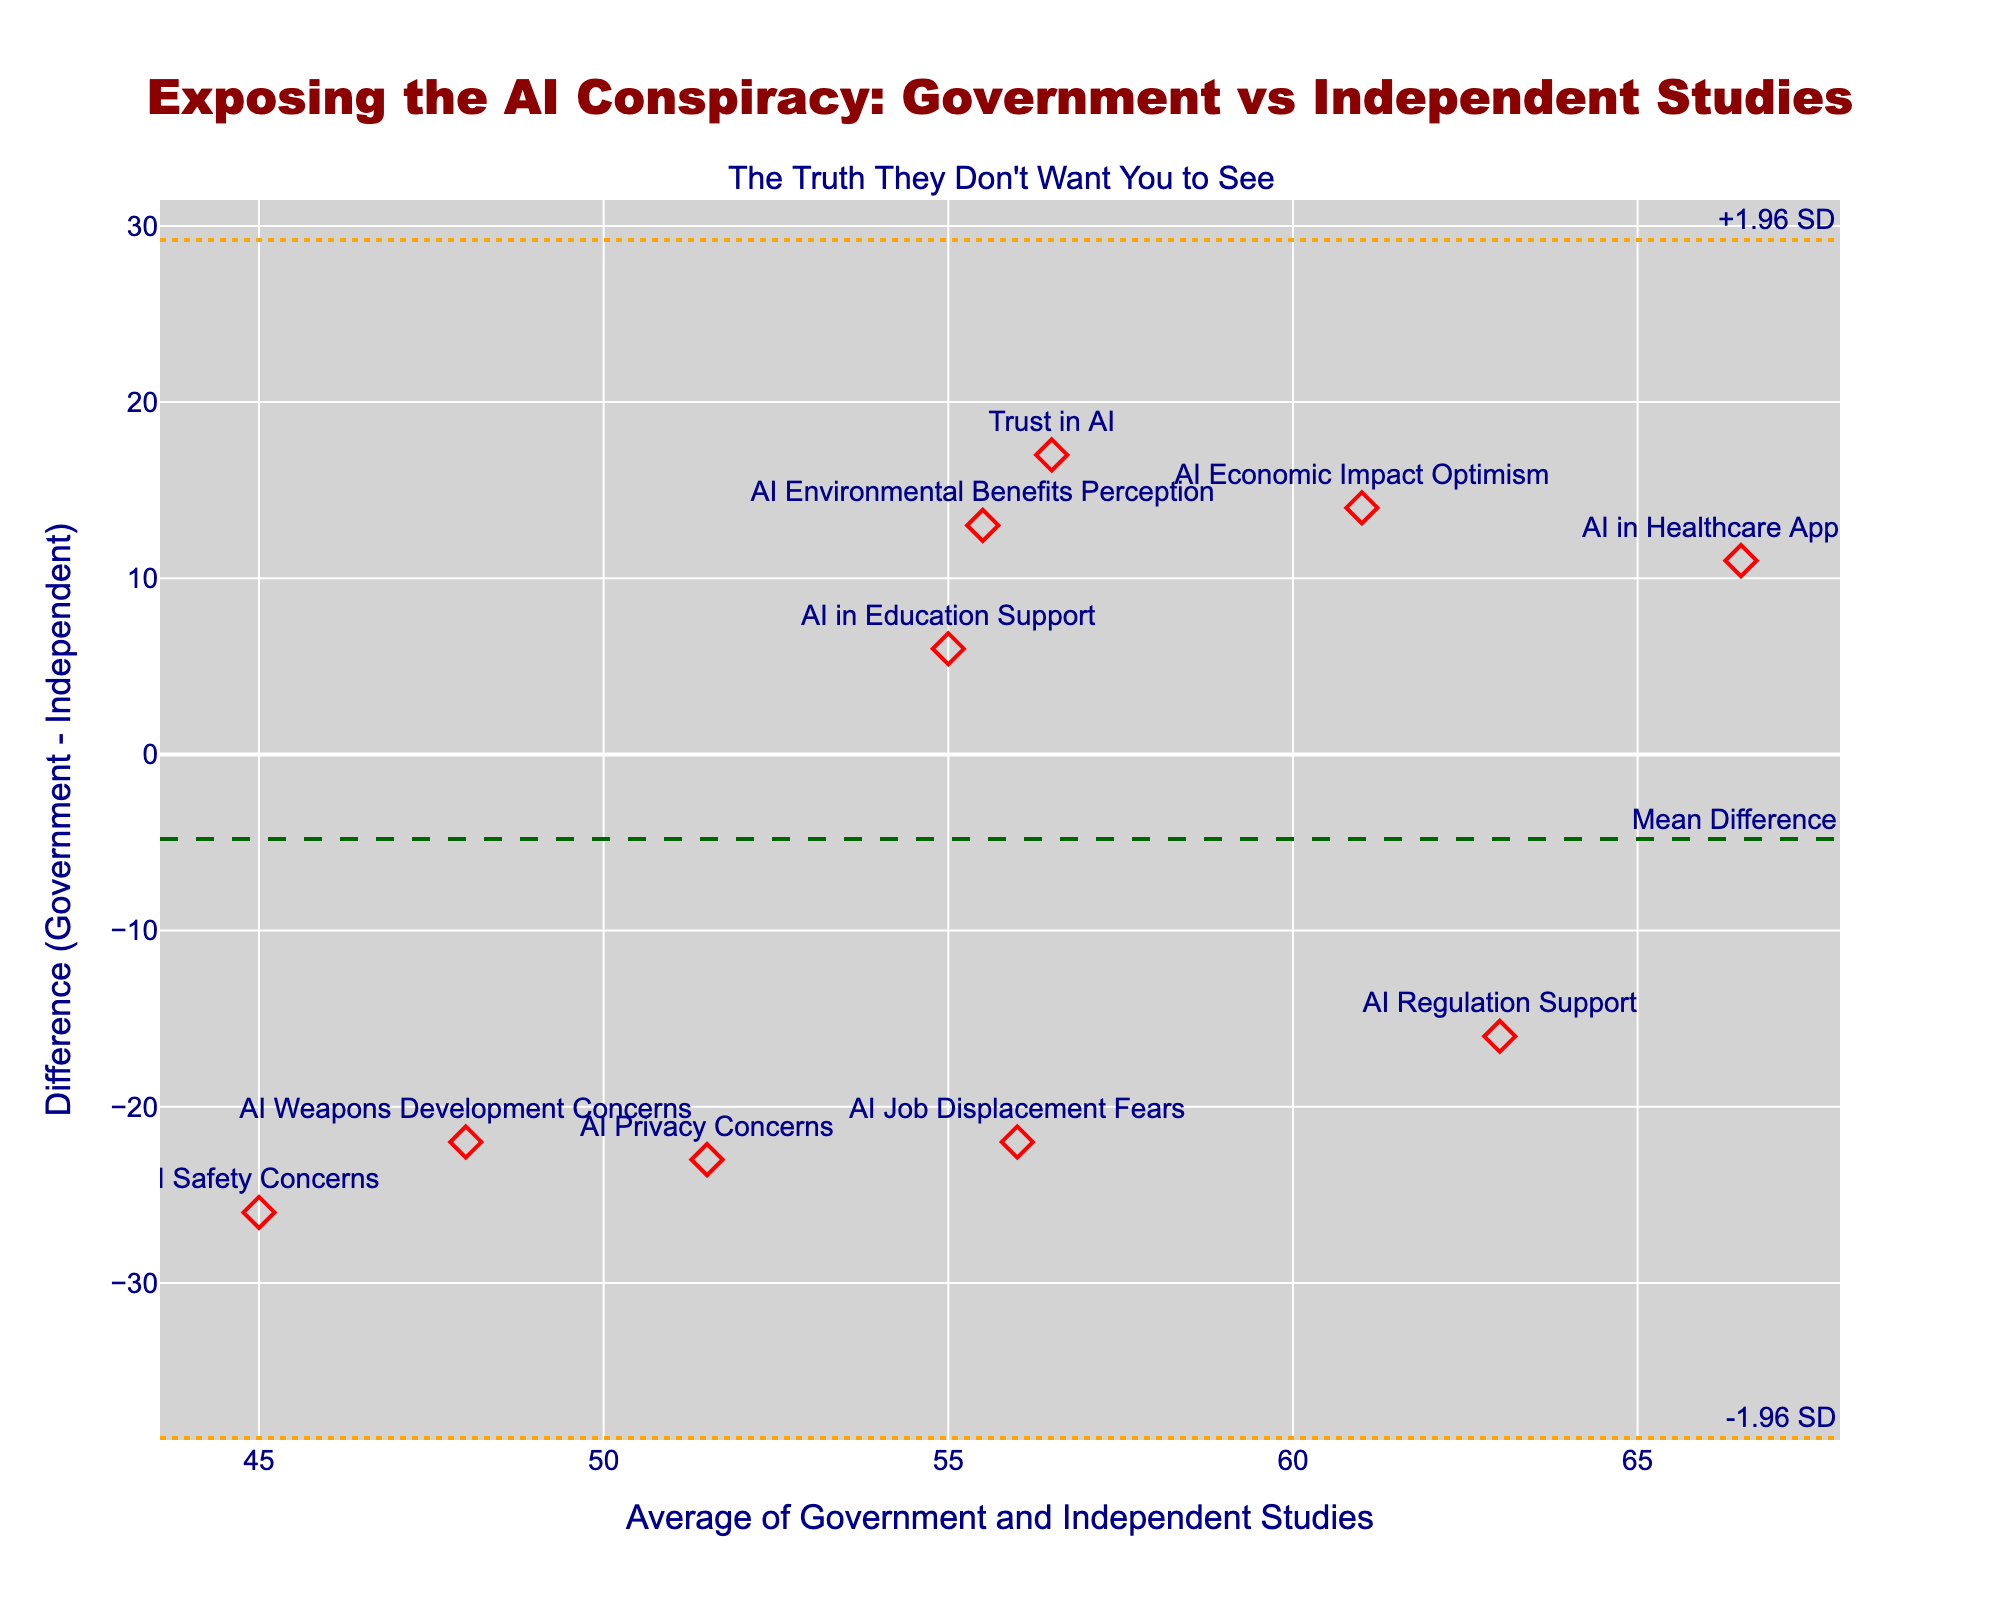How many data points are represented in the plot? The figure includes markers for each data point. By counting these markers, we find that there are 10 data points in total.
Answer: 10 What is the title of the plot? The title is present right above the plot and reads, "Exposing the AI Conspiracy: Government vs Independent Studies."
Answer: Exposing the AI Conspiracy: Government vs Independent Studies What does the dashed dark green line represent? The line is annotated with "Mean Difference," indicating that it represents the average difference between government and independent studies.
Answer: Mean Difference Which topic shows the largest negative difference between government and independent studies? By examining the data points and their associated topics, the largest negative difference of -26 is for "AI Safety Concerns."
Answer: AI Safety Concerns What is the average of the survey results for "AI Job Displacement Fears"? For "AI Job Displacement Fears," we take the average of Government Survey (45) and Independent Study (67) as (45+67)/2. Calculating this gives us an average of 56.
Answer: 56 What is the range of differences within ±1.96 standard deviations from the mean difference? The plot has horizontal lines indicating ±1.96 standard deviations. These lines are at y-values of approximately -24.5 and 20.5. Thus, the range of differences within these limits is from -24.5 to 20.5.
Answer: -24.5 to 20.5 Which data point is closest to the mean difference line? Observing the plot, the data point for "AI in Education Support" has a difference (6) which aligns closest to the dark green mean difference line.
Answer: AI in Education Support Which topic has a difference value of 13, and what is its average score? From the data, "AI Environmental Benefits Perception" has a difference of 13. The average score is calculated as (62+49)/2, which equals 55.5.
Answer: AI Environmental Benefits Perception; 55.5 What are the y-values for the two orange dotted lines? The figure labels these as plus and minus 1.96 standard deviations from the mean difference. Hence, the y-values are approximately -24.5 and 20.5.
Answer: -24.5 and 20.5 Which topic shows the highest level of trust in AI according to the government survey? Examining the data, "AI in Healthcare Approval" shows the highest government survey value of 72.
Answer: AI in Healthcare Approval 